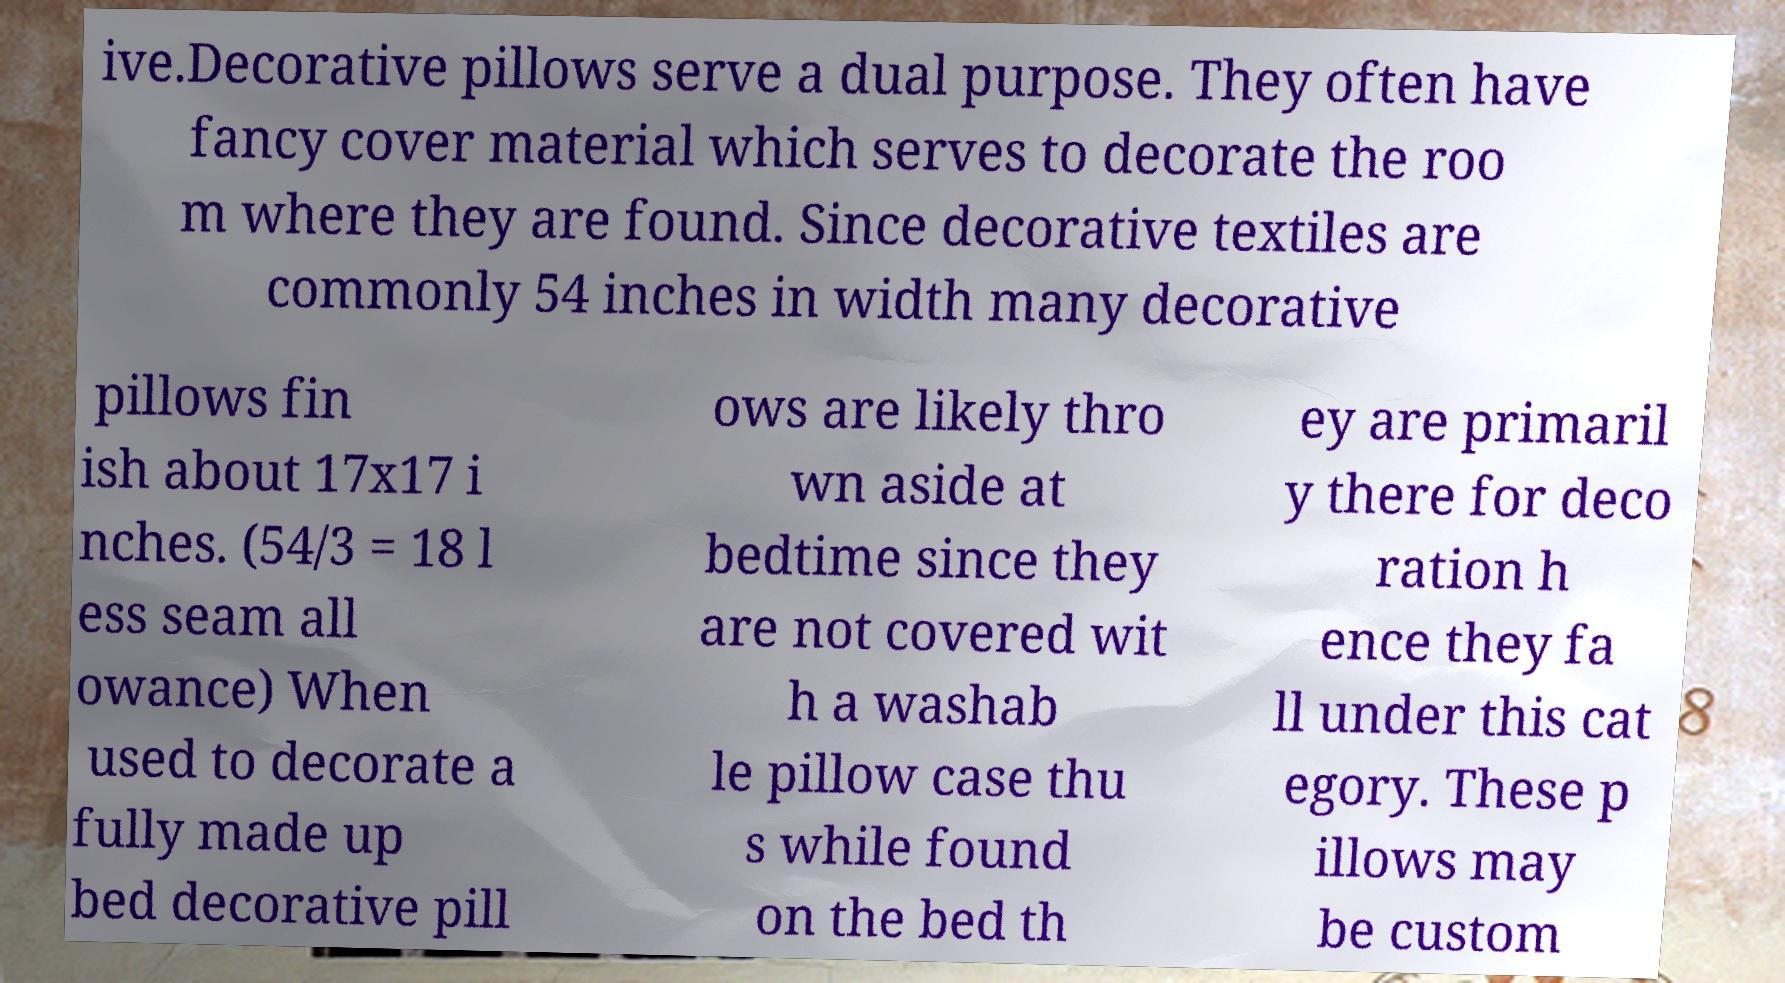Could you extract and type out the text from this image? ive.Decorative pillows serve a dual purpose. They often have fancy cover material which serves to decorate the roo m where they are found. Since decorative textiles are commonly 54 inches in width many decorative pillows fin ish about 17x17 i nches. (54/3 = 18 l ess seam all owance) When used to decorate a fully made up bed decorative pill ows are likely thro wn aside at bedtime since they are not covered wit h a washab le pillow case thu s while found on the bed th ey are primaril y there for deco ration h ence they fa ll under this cat egory. These p illows may be custom 